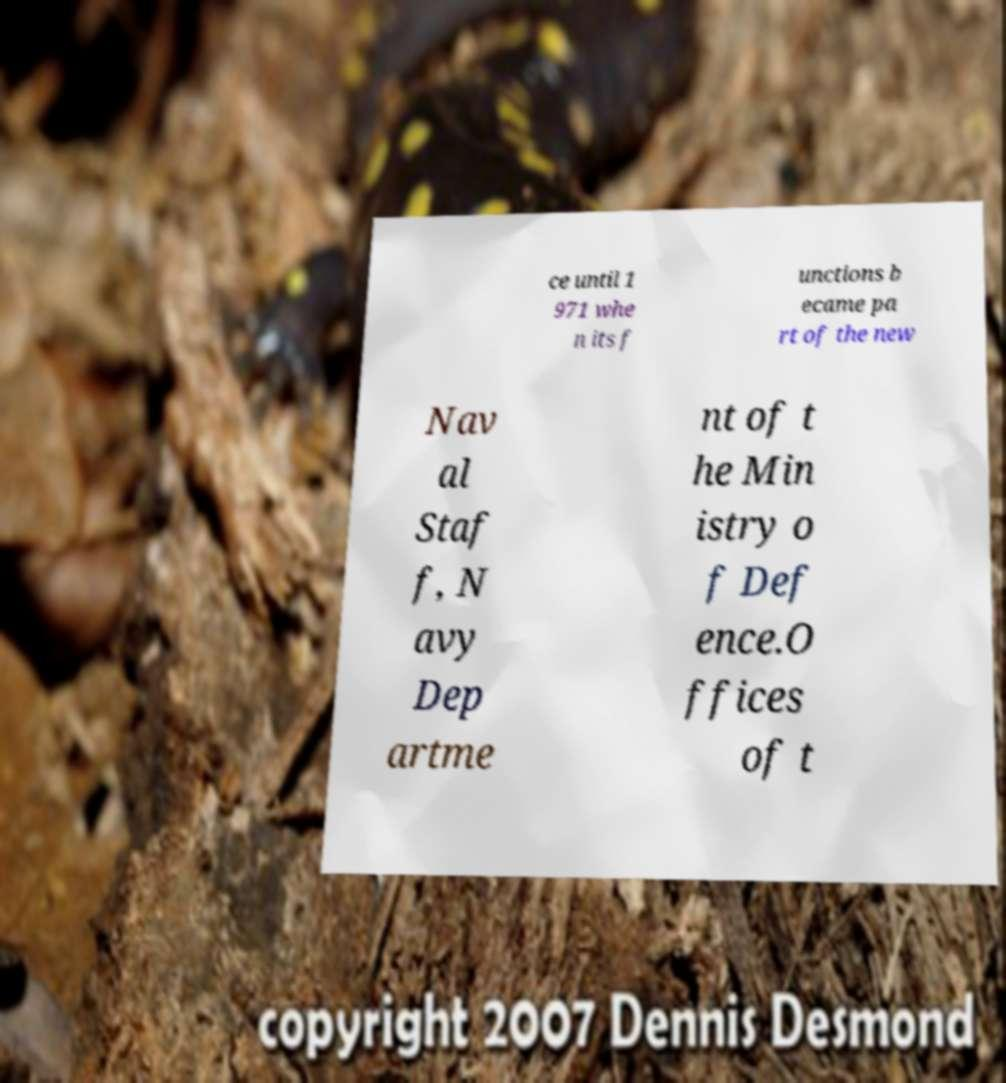Could you extract and type out the text from this image? ce until 1 971 whe n its f unctions b ecame pa rt of the new Nav al Staf f, N avy Dep artme nt of t he Min istry o f Def ence.O ffices of t 